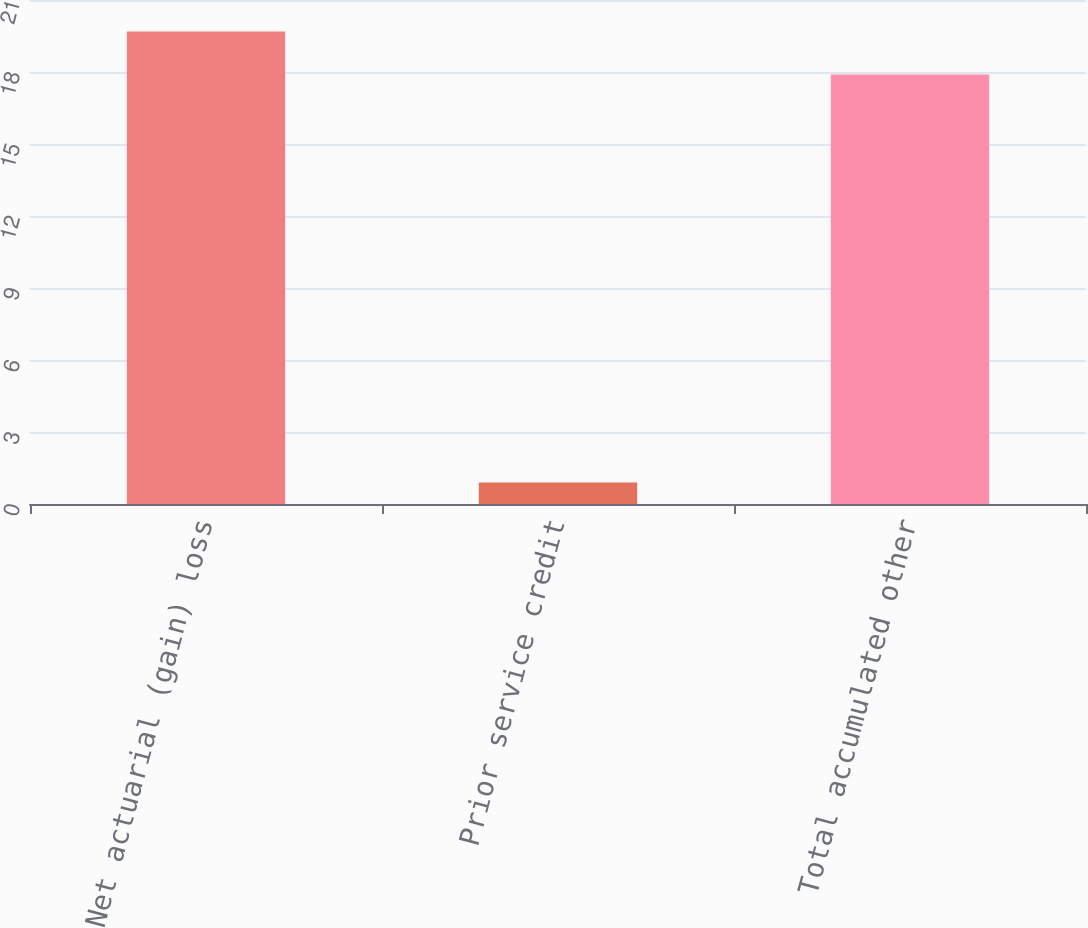Convert chart. <chart><loc_0><loc_0><loc_500><loc_500><bar_chart><fcel>Net actuarial (gain) loss<fcel>Prior service credit<fcel>Total accumulated other<nl><fcel>19.69<fcel>0.9<fcel>17.9<nl></chart> 